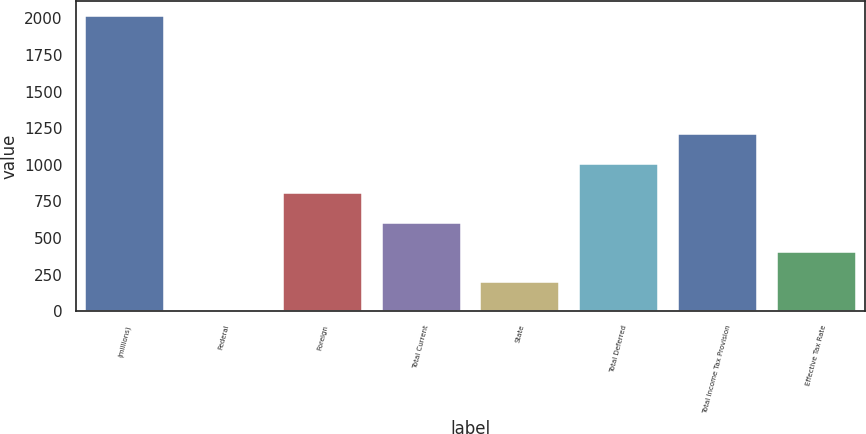Convert chart. <chart><loc_0><loc_0><loc_500><loc_500><bar_chart><fcel>(millions)<fcel>Federal<fcel>Foreign<fcel>Total Current<fcel>State<fcel>Total Deferred<fcel>Total Income Tax Provision<fcel>Effective Tax Rate<nl><fcel>2015<fcel>1<fcel>806.6<fcel>605.2<fcel>202.4<fcel>1008<fcel>1209.4<fcel>403.8<nl></chart> 